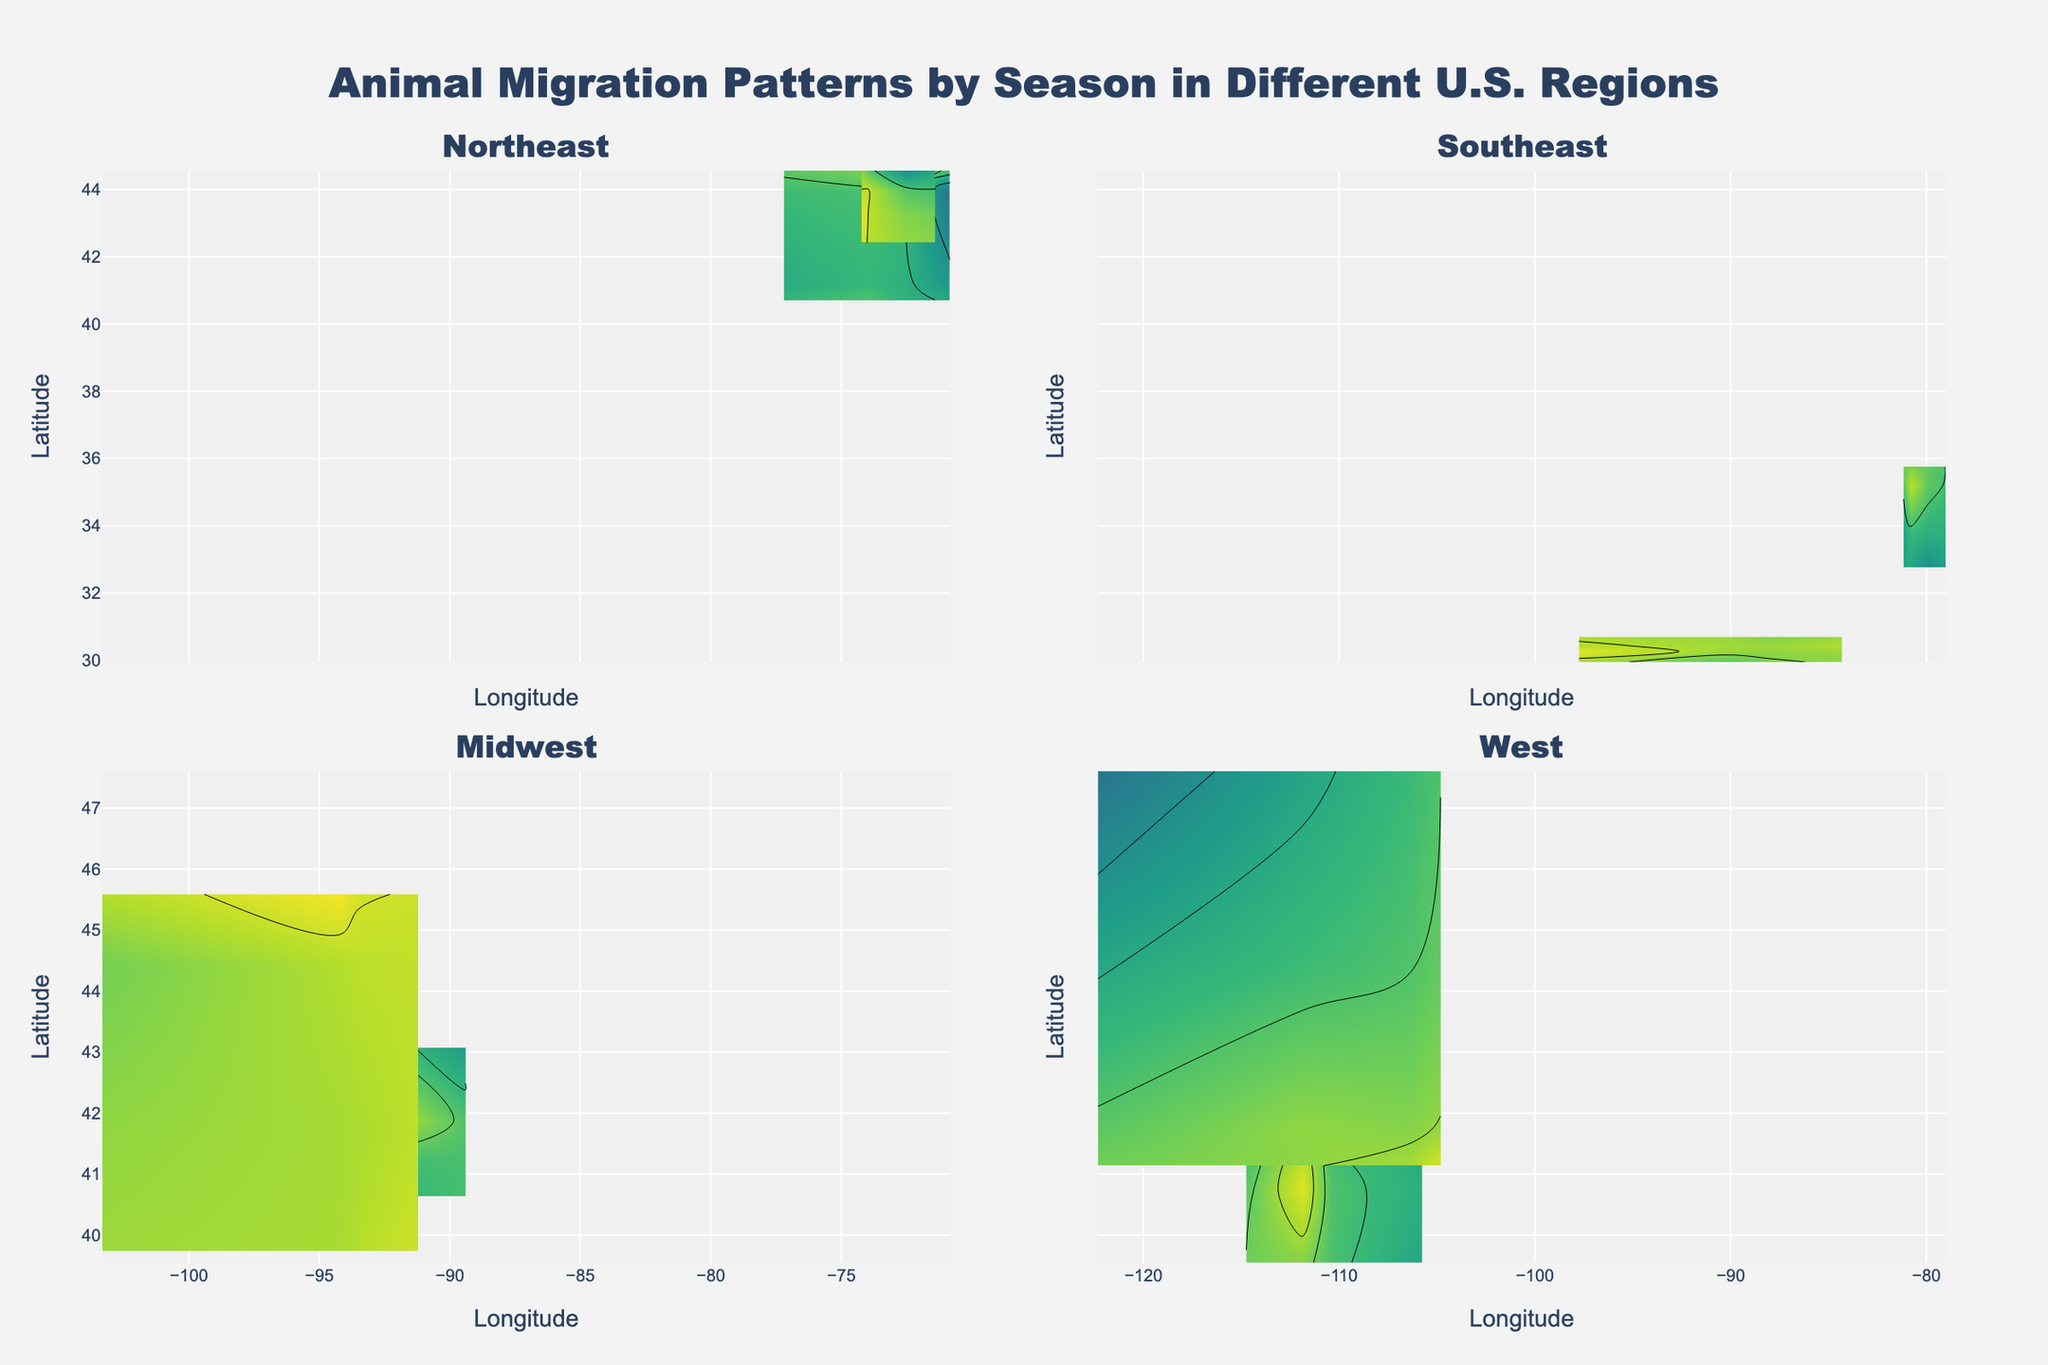What is the title of the plot? The title is at the top center of the figure, prominently displayed to describe the content of the plot. It reads: "Animal Migration Patterns by Season in Different U.S. Regions".
Answer: Animal Migration Patterns by Season in Different U.S. Regions What does the color scale represent in the contour plots? The color scale in the contour plot represents the "Count" of animals, which indicates the density or number of animals observed in a given area. Darker colors usually signify higher counts.
Answer: Count of animals Which region has the highest count for Elk during Fall? To find this, we need to locate the subplots for the "West" region and identify the patterns corresponding to 'Elk' among different seasons. According to the color shades, the highest count for Elk during Fall is visible in the figure.
Answer: West How does the count of Ducks in Winter compare between the Southeast and Midwest regions? By comparing the color scales and contour values for 'Ducks' during Winter in both Southeast and Midwest regions’ subplots, we can discern which has greater density based on darker colors indicating higher counts.
Answer: Southeast has higher count What is the range of latitudes for the White-tailed Deer in the Northeast across all seasons? For this, we need to look at all the data points in the subplots showing 'White-tailed Deer' in the Northeast region across different seasons. The latitude values range from the lowest to the highest points shown.
Answer: Approximately 40.7 to 44.6 How does the migration pattern of Black Bear in Spring differ from Summer in the Southeast region in terms of location and density? We need to inspect the subplot for the Southeast region and compare the 'Black Bear' contours between Spring and Summer. Observe changes in locations (longitude and latitude) and color density for differences in migration patterns.
Answer: Spring covers a broader range, Summer is more localized and less dense What are the notable differences in the migration patterns of Whitetail Deer between the Midwest and West regions during Fall? Focus on the Midwest and West regions’ subplots during Fall for 'Whitetail Deer'. Compare color contours, latitude, and longitude ranges to observe any differences in migration patterns, such as density and spread.
Answer: Midwest has higher density, West has broader range In which season do Wild Turkeys in the Northeast have the lowest count, and what is the value? By visually examining the Northeast subplots for 'Wild Turkey', identify the season with the lightest color contour. Check the values associated with this contour.
Answer: Winter, count is 10 How are the migration patterns of Pronghorn in the West region distributed across different seasons in terms of latitude? To answer, look at the West region subplots and observe the latitude values of the contour plots for 'Pronghorn' across different seasons. Summarize the distribution trends.
Answer: From approximately 41 to 47, shifts northwards in Winter What can be inferred about the migration density of Pheasants in the Midwest during Summer compared to Winter? Observe and compare the color density of 'Pheasants' contours between Summer and Winter within the Midwest subplot to infer changes in migration density.
Answer: Denser in Summer than in Winter 